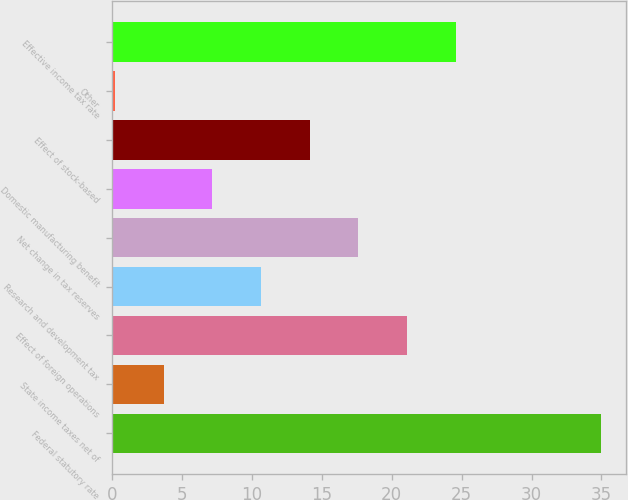<chart> <loc_0><loc_0><loc_500><loc_500><bar_chart><fcel>Federal statutory rate<fcel>State income taxes net of<fcel>Effect of foreign operations<fcel>Research and development tax<fcel>Net change in tax reserves<fcel>Domestic manufacturing benefit<fcel>Effect of stock-based<fcel>Other<fcel>Effective income tax rate<nl><fcel>35<fcel>3.68<fcel>21.08<fcel>10.64<fcel>17.6<fcel>7.16<fcel>14.12<fcel>0.2<fcel>24.56<nl></chart> 